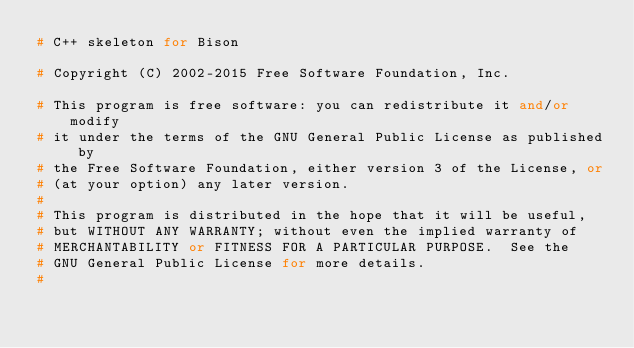Convert code to text. <code><loc_0><loc_0><loc_500><loc_500><_C++_># C++ skeleton for Bison

# Copyright (C) 2002-2015 Free Software Foundation, Inc.

# This program is free software: you can redistribute it and/or modify
# it under the terms of the GNU General Public License as published by
# the Free Software Foundation, either version 3 of the License, or
# (at your option) any later version.
#
# This program is distributed in the hope that it will be useful,
# but WITHOUT ANY WARRANTY; without even the implied warranty of
# MERCHANTABILITY or FITNESS FOR A PARTICULAR PURPOSE.  See the
# GNU General Public License for more details.
#</code> 